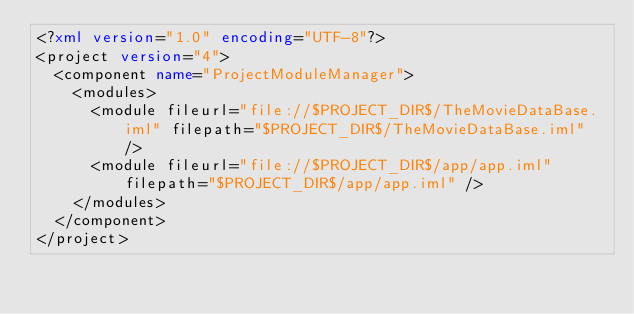<code> <loc_0><loc_0><loc_500><loc_500><_XML_><?xml version="1.0" encoding="UTF-8"?>
<project version="4">
  <component name="ProjectModuleManager">
    <modules>
      <module fileurl="file://$PROJECT_DIR$/TheMovieDataBase.iml" filepath="$PROJECT_DIR$/TheMovieDataBase.iml" />
      <module fileurl="file://$PROJECT_DIR$/app/app.iml" filepath="$PROJECT_DIR$/app/app.iml" />
    </modules>
  </component>
</project></code> 